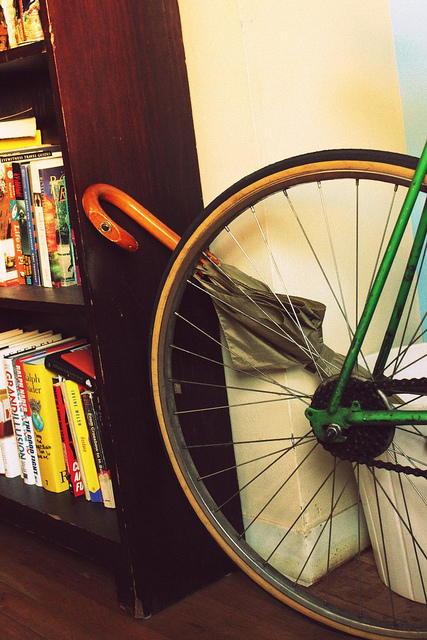What does the bike wheel signify? The presence of the bike wheel may signify a lifestyle choice favoring eco-friendly transport, a personal affinity for cycling, or it could be an innovative interior design element. It also adds a dynamic contrast to the static books, blending mobility with intellectual pursuits. 